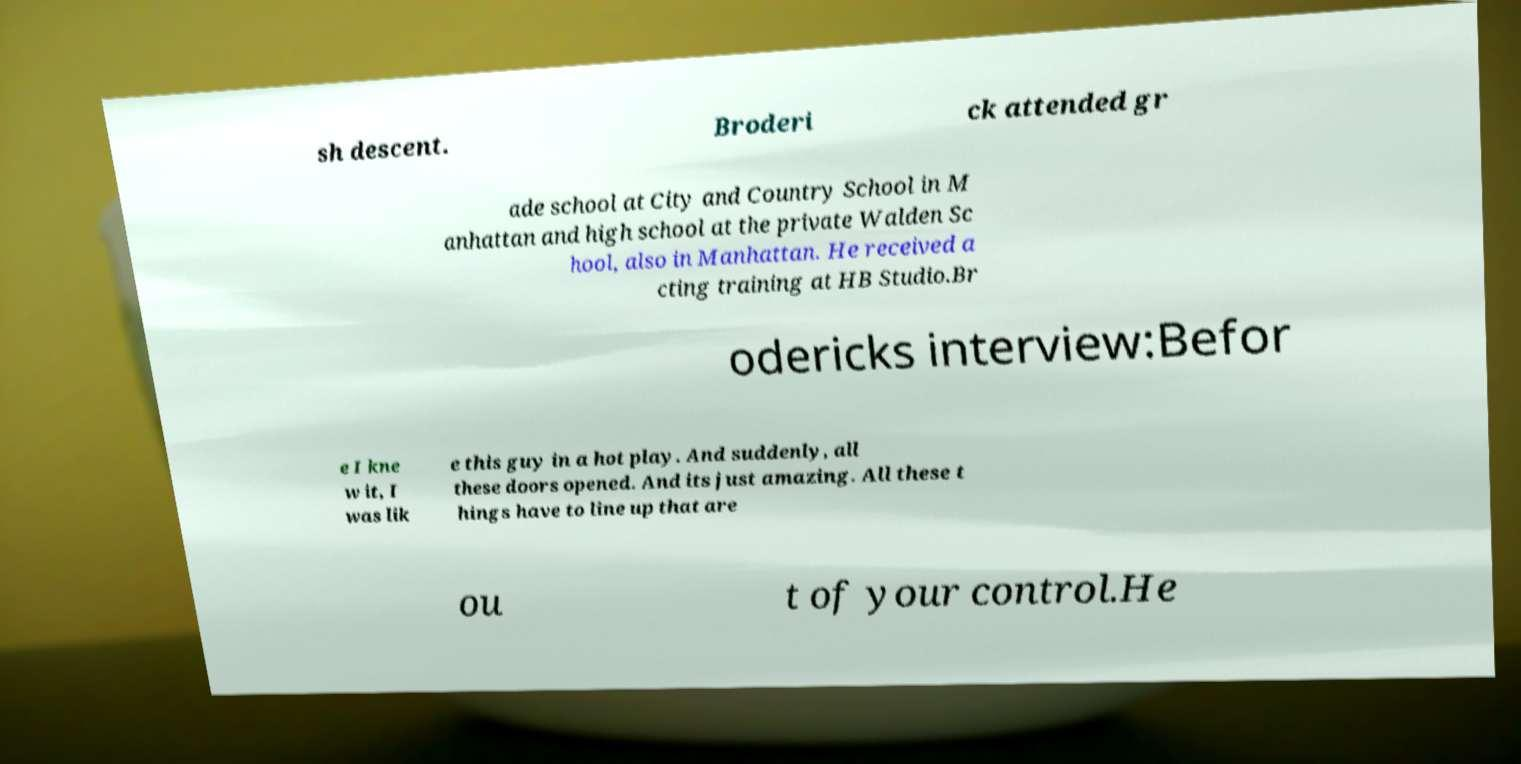Could you extract and type out the text from this image? sh descent. Broderi ck attended gr ade school at City and Country School in M anhattan and high school at the private Walden Sc hool, also in Manhattan. He received a cting training at HB Studio.Br odericks interview:Befor e I kne w it, I was lik e this guy in a hot play. And suddenly, all these doors opened. And its just amazing. All these t hings have to line up that are ou t of your control.He 